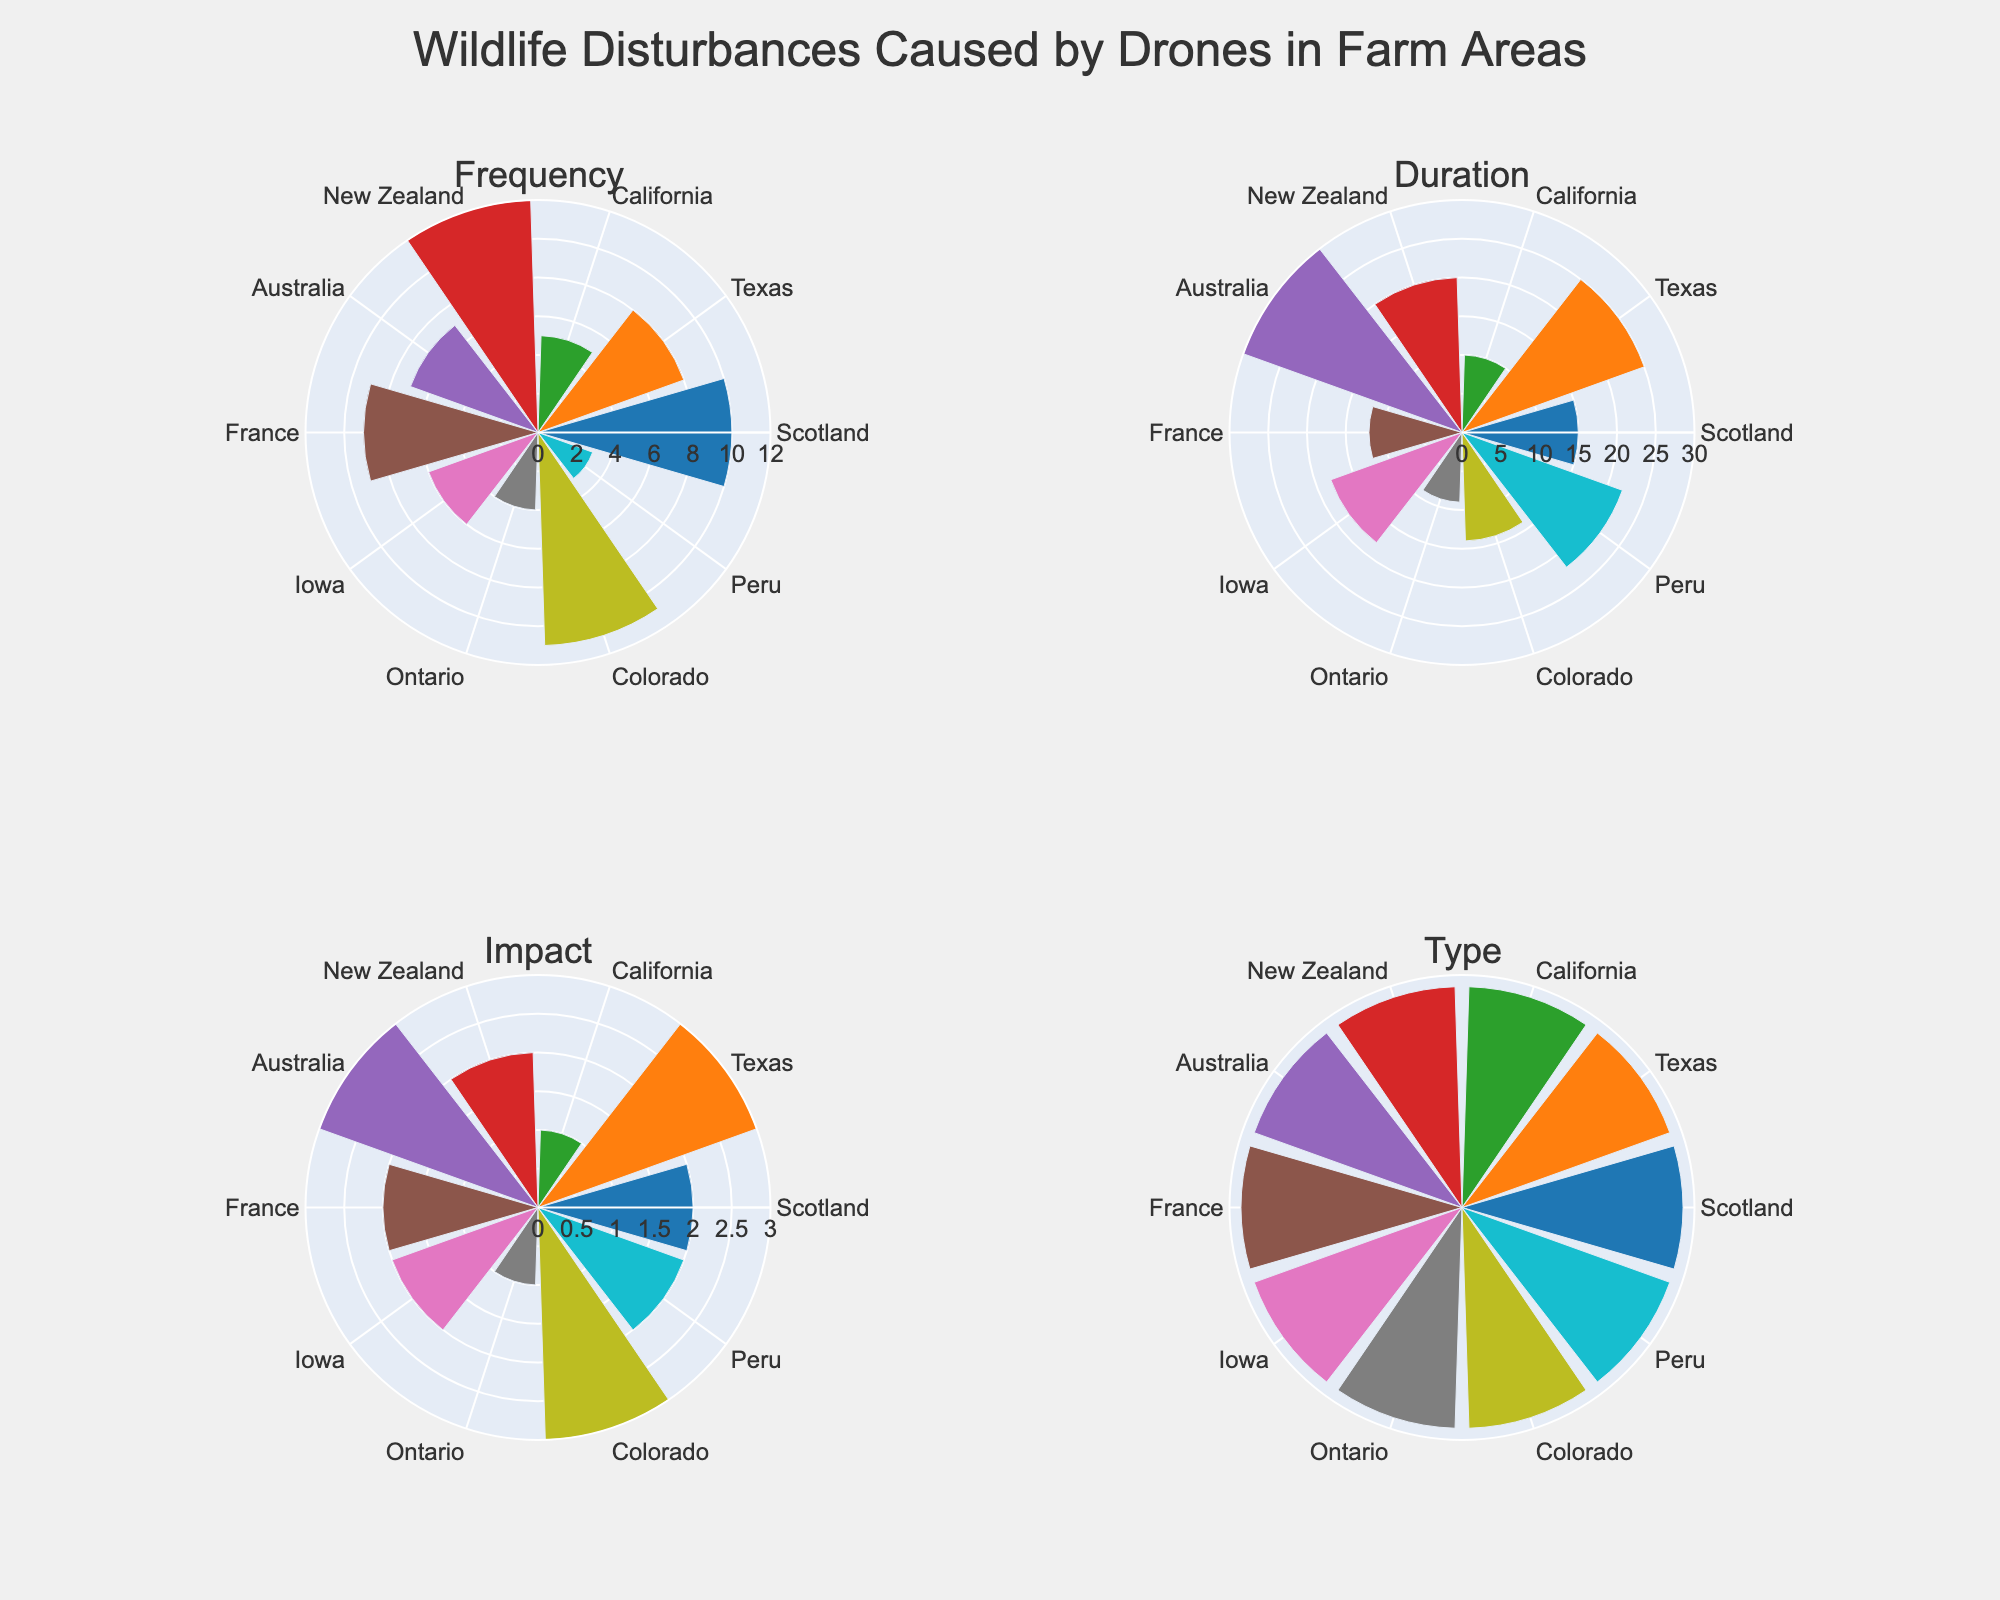what is the title of the figure? The title of the figure is displayed at the top of the chart.
Answer: Wildlife Disturbances Caused by Drones in Farm Areas How many regions are represented in the "Frequency" subplot? The "Frequency" subplot shows bars labeled with different regions. By counting the labels, we find the number of regions represented.
Answer: 10 Which region has the highest duration of wildlife disturbance caused by drones? In the "Duration" subplot, the height of each bar represents the duration of disturbance. The highest bar corresponds to the region with the highest duration.
Answer: Australia Compare the impact of drone disturbances between Sheep in Scotland and Goats in New Zealand. Which one is higher? By examining the "Impact" subplot, we can compare the height of the bars corresponding to Scotland and New Zealand. The region with the higher bar is the one with the higher impact.
Answer: New Zealand What type of livestock in Texas is impacted by drone disturbances, and what is the impact level? The "Type" subplot indicates different livestock types for each region, while the "Impact" subplot shows varying impact levels. Refer to both subplots for the information specific to Texas.
Answer: Cattle, High In which region do ducks experience drone disturbances, and what is the frequency of those disturbances? The "Type" subplot can be used to identify the livestock associated with each region. From there, reference the "Frequency" subplot to find the specific frequency for that region.
Answer: France, 9 Which region has the lowest impact from drone disturbances on livestock? By looking at the "Impact" subplot, we can find the region associated with the lowest bar height, indicating the lowest impact.
Answer: Ontario Is the impact on horses in Australia higher or lower than the impact on deer in Colorado? The "Impact" subplot shows the relative heights of bars for each region. Comparing Australia and Colorado will show which has the higher impact.
Answer: Lower Calculate the average duration of drone disturbances across all regions. Average is calculated by summing up the duration values and dividing by the number of regions. Sum the values (15 + 25 + 10 + 20 + 30 + 12 + 18 + 9 + 14 + 22) which equals 175, then divide by the number of regions (10).
Answer: 17.5 Which type of livestock has an impact categorized as moderate in New Zealand? The "Type" subplot contains information about the specific livestock in each region, and the "Impact" subplot shows the impact level. Locate New Zealand in both.
Answer: Goats 